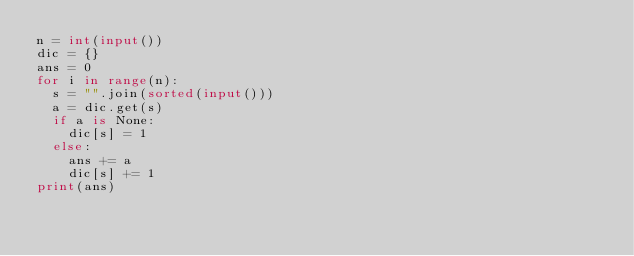<code> <loc_0><loc_0><loc_500><loc_500><_Python_>n = int(input())
dic = {}
ans = 0
for i in range(n):
  s = "".join(sorted(input()))
  a = dic.get(s)
  if a is None:
    dic[s] = 1
  else:
    ans += a
    dic[s] += 1
print(ans)</code> 